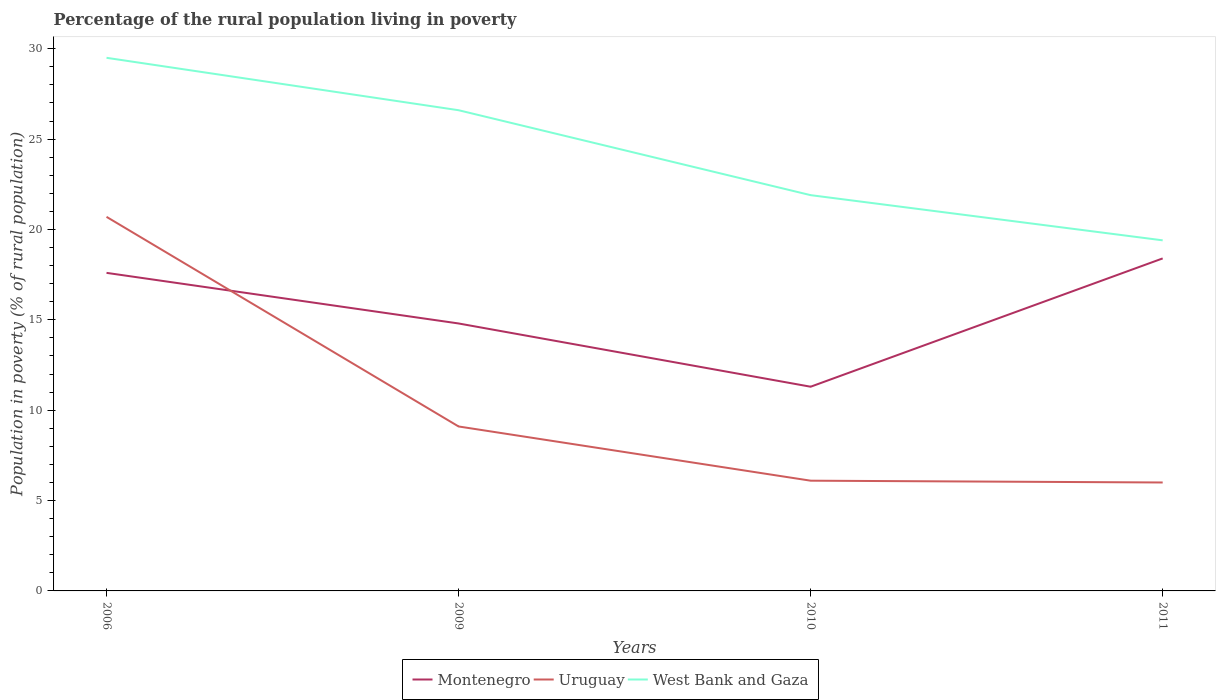Is the number of lines equal to the number of legend labels?
Your answer should be very brief. Yes. In which year was the percentage of the rural population living in poverty in Montenegro maximum?
Provide a short and direct response. 2010. What is the difference between the highest and the second highest percentage of the rural population living in poverty in West Bank and Gaza?
Your response must be concise. 10.1. What is the difference between the highest and the lowest percentage of the rural population living in poverty in West Bank and Gaza?
Keep it short and to the point. 2. Is the percentage of the rural population living in poverty in Montenegro strictly greater than the percentage of the rural population living in poverty in Uruguay over the years?
Provide a succinct answer. No. How many lines are there?
Your answer should be compact. 3. Are the values on the major ticks of Y-axis written in scientific E-notation?
Keep it short and to the point. No. Does the graph contain grids?
Your answer should be very brief. No. What is the title of the graph?
Your response must be concise. Percentage of the rural population living in poverty. What is the label or title of the Y-axis?
Give a very brief answer. Population in poverty (% of rural population). What is the Population in poverty (% of rural population) in Montenegro in 2006?
Your response must be concise. 17.6. What is the Population in poverty (% of rural population) of Uruguay in 2006?
Your response must be concise. 20.7. What is the Population in poverty (% of rural population) of West Bank and Gaza in 2006?
Provide a short and direct response. 29.5. What is the Population in poverty (% of rural population) of West Bank and Gaza in 2009?
Offer a terse response. 26.6. What is the Population in poverty (% of rural population) in West Bank and Gaza in 2010?
Give a very brief answer. 21.9. What is the Population in poverty (% of rural population) of West Bank and Gaza in 2011?
Provide a succinct answer. 19.4. Across all years, what is the maximum Population in poverty (% of rural population) in Uruguay?
Ensure brevity in your answer.  20.7. Across all years, what is the maximum Population in poverty (% of rural population) of West Bank and Gaza?
Provide a succinct answer. 29.5. Across all years, what is the minimum Population in poverty (% of rural population) of Uruguay?
Make the answer very short. 6. What is the total Population in poverty (% of rural population) in Montenegro in the graph?
Make the answer very short. 62.1. What is the total Population in poverty (% of rural population) of Uruguay in the graph?
Your answer should be compact. 41.9. What is the total Population in poverty (% of rural population) in West Bank and Gaza in the graph?
Your answer should be very brief. 97.4. What is the difference between the Population in poverty (% of rural population) in Montenegro in 2006 and that in 2009?
Make the answer very short. 2.8. What is the difference between the Population in poverty (% of rural population) in Uruguay in 2006 and that in 2009?
Provide a short and direct response. 11.6. What is the difference between the Population in poverty (% of rural population) in West Bank and Gaza in 2006 and that in 2009?
Offer a terse response. 2.9. What is the difference between the Population in poverty (% of rural population) of Montenegro in 2006 and that in 2010?
Your response must be concise. 6.3. What is the difference between the Population in poverty (% of rural population) of Uruguay in 2006 and that in 2011?
Offer a terse response. 14.7. What is the difference between the Population in poverty (% of rural population) in West Bank and Gaza in 2006 and that in 2011?
Give a very brief answer. 10.1. What is the difference between the Population in poverty (% of rural population) in Uruguay in 2009 and that in 2010?
Offer a terse response. 3. What is the difference between the Population in poverty (% of rural population) of West Bank and Gaza in 2009 and that in 2011?
Ensure brevity in your answer.  7.2. What is the difference between the Population in poverty (% of rural population) in Uruguay in 2006 and the Population in poverty (% of rural population) in West Bank and Gaza in 2009?
Ensure brevity in your answer.  -5.9. What is the difference between the Population in poverty (% of rural population) of Montenegro in 2006 and the Population in poverty (% of rural population) of West Bank and Gaza in 2010?
Provide a succinct answer. -4.3. What is the difference between the Population in poverty (% of rural population) of Montenegro in 2006 and the Population in poverty (% of rural population) of Uruguay in 2011?
Offer a very short reply. 11.6. What is the difference between the Population in poverty (% of rural population) of Uruguay in 2006 and the Population in poverty (% of rural population) of West Bank and Gaza in 2011?
Provide a succinct answer. 1.3. What is the difference between the Population in poverty (% of rural population) in Montenegro in 2009 and the Population in poverty (% of rural population) in West Bank and Gaza in 2010?
Offer a terse response. -7.1. What is the difference between the Population in poverty (% of rural population) of Uruguay in 2009 and the Population in poverty (% of rural population) of West Bank and Gaza in 2010?
Make the answer very short. -12.8. What is the difference between the Population in poverty (% of rural population) in Montenegro in 2009 and the Population in poverty (% of rural population) in Uruguay in 2011?
Give a very brief answer. 8.8. What is the difference between the Population in poverty (% of rural population) in Montenegro in 2009 and the Population in poverty (% of rural population) in West Bank and Gaza in 2011?
Keep it short and to the point. -4.6. What is the difference between the Population in poverty (% of rural population) in Uruguay in 2009 and the Population in poverty (% of rural population) in West Bank and Gaza in 2011?
Offer a very short reply. -10.3. What is the difference between the Population in poverty (% of rural population) in Montenegro in 2010 and the Population in poverty (% of rural population) in Uruguay in 2011?
Your response must be concise. 5.3. What is the difference between the Population in poverty (% of rural population) of Uruguay in 2010 and the Population in poverty (% of rural population) of West Bank and Gaza in 2011?
Ensure brevity in your answer.  -13.3. What is the average Population in poverty (% of rural population) in Montenegro per year?
Your answer should be very brief. 15.53. What is the average Population in poverty (% of rural population) of Uruguay per year?
Keep it short and to the point. 10.47. What is the average Population in poverty (% of rural population) of West Bank and Gaza per year?
Offer a very short reply. 24.35. In the year 2006, what is the difference between the Population in poverty (% of rural population) of Uruguay and Population in poverty (% of rural population) of West Bank and Gaza?
Provide a short and direct response. -8.8. In the year 2009, what is the difference between the Population in poverty (% of rural population) of Montenegro and Population in poverty (% of rural population) of Uruguay?
Give a very brief answer. 5.7. In the year 2009, what is the difference between the Population in poverty (% of rural population) of Montenegro and Population in poverty (% of rural population) of West Bank and Gaza?
Your answer should be very brief. -11.8. In the year 2009, what is the difference between the Population in poverty (% of rural population) in Uruguay and Population in poverty (% of rural population) in West Bank and Gaza?
Provide a succinct answer. -17.5. In the year 2010, what is the difference between the Population in poverty (% of rural population) of Montenegro and Population in poverty (% of rural population) of West Bank and Gaza?
Your answer should be compact. -10.6. In the year 2010, what is the difference between the Population in poverty (% of rural population) of Uruguay and Population in poverty (% of rural population) of West Bank and Gaza?
Offer a very short reply. -15.8. In the year 2011, what is the difference between the Population in poverty (% of rural population) of Montenegro and Population in poverty (% of rural population) of Uruguay?
Offer a very short reply. 12.4. In the year 2011, what is the difference between the Population in poverty (% of rural population) of Montenegro and Population in poverty (% of rural population) of West Bank and Gaza?
Make the answer very short. -1. In the year 2011, what is the difference between the Population in poverty (% of rural population) in Uruguay and Population in poverty (% of rural population) in West Bank and Gaza?
Keep it short and to the point. -13.4. What is the ratio of the Population in poverty (% of rural population) of Montenegro in 2006 to that in 2009?
Offer a terse response. 1.19. What is the ratio of the Population in poverty (% of rural population) of Uruguay in 2006 to that in 2009?
Provide a short and direct response. 2.27. What is the ratio of the Population in poverty (% of rural population) in West Bank and Gaza in 2006 to that in 2009?
Your answer should be very brief. 1.11. What is the ratio of the Population in poverty (% of rural population) of Montenegro in 2006 to that in 2010?
Give a very brief answer. 1.56. What is the ratio of the Population in poverty (% of rural population) in Uruguay in 2006 to that in 2010?
Ensure brevity in your answer.  3.39. What is the ratio of the Population in poverty (% of rural population) of West Bank and Gaza in 2006 to that in 2010?
Give a very brief answer. 1.35. What is the ratio of the Population in poverty (% of rural population) of Montenegro in 2006 to that in 2011?
Your response must be concise. 0.96. What is the ratio of the Population in poverty (% of rural population) of Uruguay in 2006 to that in 2011?
Make the answer very short. 3.45. What is the ratio of the Population in poverty (% of rural population) of West Bank and Gaza in 2006 to that in 2011?
Your answer should be very brief. 1.52. What is the ratio of the Population in poverty (% of rural population) of Montenegro in 2009 to that in 2010?
Make the answer very short. 1.31. What is the ratio of the Population in poverty (% of rural population) in Uruguay in 2009 to that in 2010?
Offer a terse response. 1.49. What is the ratio of the Population in poverty (% of rural population) of West Bank and Gaza in 2009 to that in 2010?
Give a very brief answer. 1.21. What is the ratio of the Population in poverty (% of rural population) in Montenegro in 2009 to that in 2011?
Give a very brief answer. 0.8. What is the ratio of the Population in poverty (% of rural population) in Uruguay in 2009 to that in 2011?
Offer a very short reply. 1.52. What is the ratio of the Population in poverty (% of rural population) in West Bank and Gaza in 2009 to that in 2011?
Make the answer very short. 1.37. What is the ratio of the Population in poverty (% of rural population) of Montenegro in 2010 to that in 2011?
Provide a succinct answer. 0.61. What is the ratio of the Population in poverty (% of rural population) in Uruguay in 2010 to that in 2011?
Offer a very short reply. 1.02. What is the ratio of the Population in poverty (% of rural population) of West Bank and Gaza in 2010 to that in 2011?
Offer a very short reply. 1.13. What is the difference between the highest and the second highest Population in poverty (% of rural population) in Montenegro?
Your response must be concise. 0.8. What is the difference between the highest and the second highest Population in poverty (% of rural population) in West Bank and Gaza?
Ensure brevity in your answer.  2.9. 